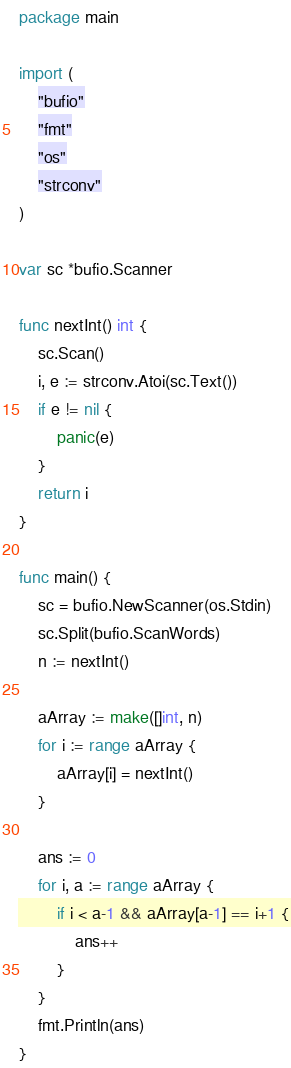Convert code to text. <code><loc_0><loc_0><loc_500><loc_500><_Go_>package main

import (
	"bufio"
	"fmt"
	"os"
	"strconv"
)

var sc *bufio.Scanner

func nextInt() int {
	sc.Scan()
	i, e := strconv.Atoi(sc.Text())
	if e != nil {
		panic(e)
	}
	return i
}

func main() {
	sc = bufio.NewScanner(os.Stdin)
	sc.Split(bufio.ScanWords)
	n := nextInt()

	aArray := make([]int, n)
	for i := range aArray {
		aArray[i] = nextInt()
	}

	ans := 0
	for i, a := range aArray {
		if i < a-1 && aArray[a-1] == i+1 {
			ans++
		}
	}
	fmt.Println(ans)
}
</code> 